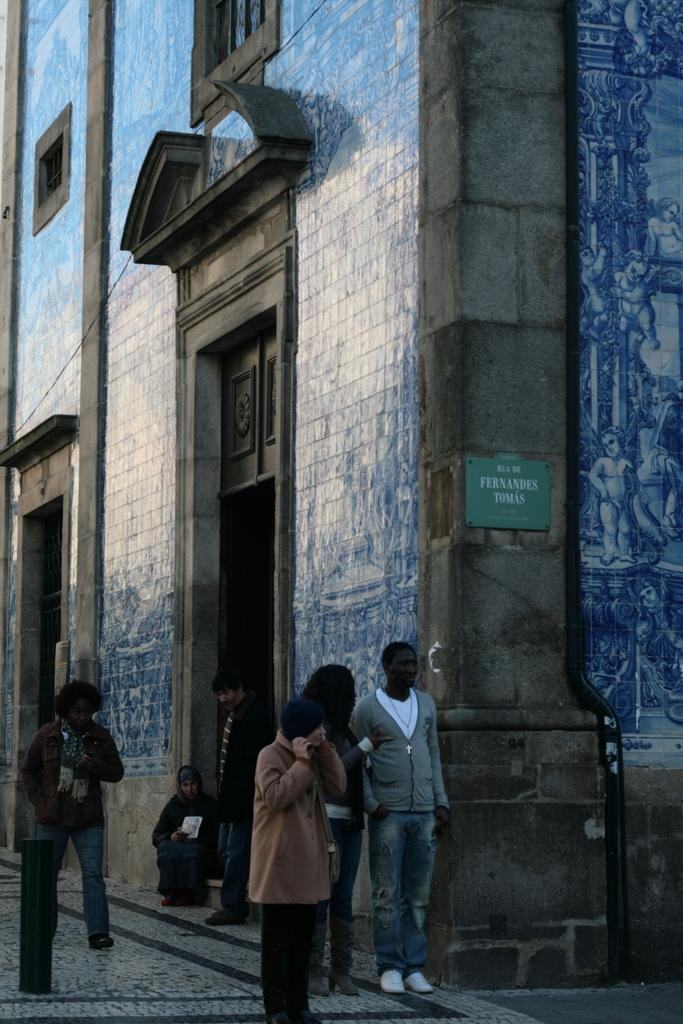What type of structures can be seen in the image? There are buildings in the image. Can you identify any specific features of the buildings? There is at least one door visible in the image. Are there any living beings present in the image? Yes, there are people present in the image. What type of card can be seen being played by the people in the image? There is no card or card game present in the image; it only shows buildings, a door, and people. 